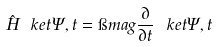Convert formula to latex. <formula><loc_0><loc_0><loc_500><loc_500>\hat { H } \ k e t { \Psi , t } = \i m a g \frac { \partial } { \partial t } \ k e t { \Psi , t }</formula> 